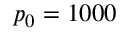<formula> <loc_0><loc_0><loc_500><loc_500>p _ { 0 } = 1 0 0 0</formula> 